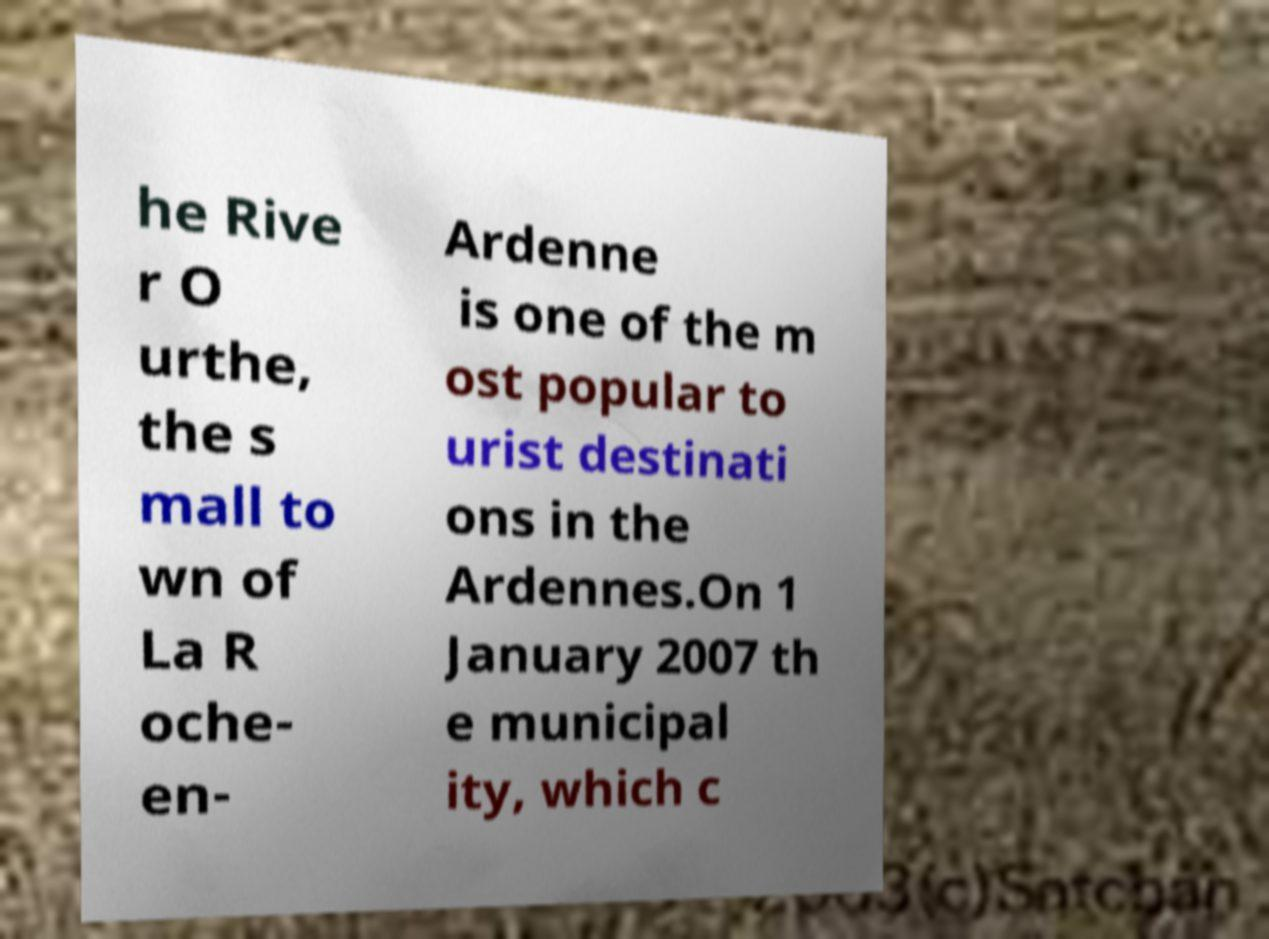Can you read and provide the text displayed in the image?This photo seems to have some interesting text. Can you extract and type it out for me? he Rive r O urthe, the s mall to wn of La R oche- en- Ardenne is one of the m ost popular to urist destinati ons in the Ardennes.On 1 January 2007 th e municipal ity, which c 